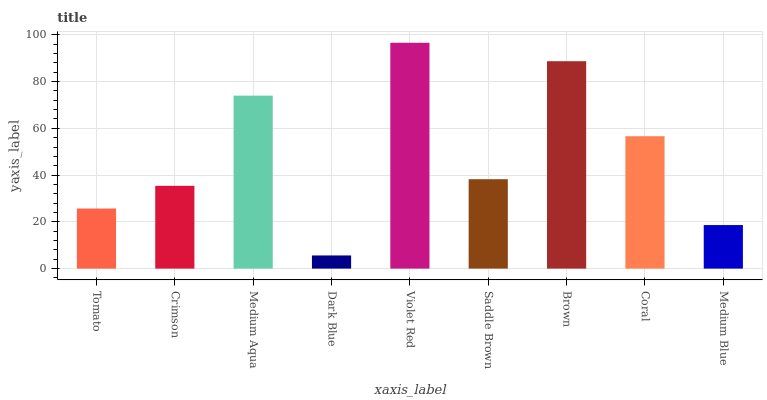Is Dark Blue the minimum?
Answer yes or no. Yes. Is Violet Red the maximum?
Answer yes or no. Yes. Is Crimson the minimum?
Answer yes or no. No. Is Crimson the maximum?
Answer yes or no. No. Is Crimson greater than Tomato?
Answer yes or no. Yes. Is Tomato less than Crimson?
Answer yes or no. Yes. Is Tomato greater than Crimson?
Answer yes or no. No. Is Crimson less than Tomato?
Answer yes or no. No. Is Saddle Brown the high median?
Answer yes or no. Yes. Is Saddle Brown the low median?
Answer yes or no. Yes. Is Medium Blue the high median?
Answer yes or no. No. Is Violet Red the low median?
Answer yes or no. No. 